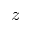<formula> <loc_0><loc_0><loc_500><loc_500>z</formula> 